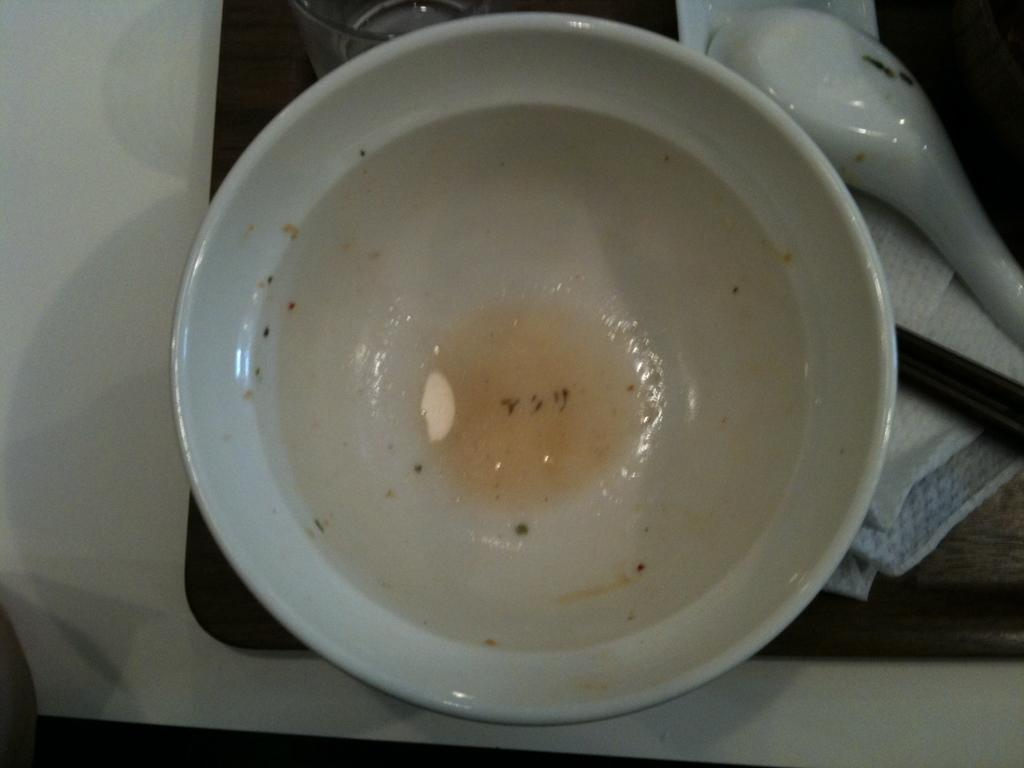What is located in the foreground area of the image? In the foreground area of the image, there is a bowl, a spoon, and a tissue. What might be used for eating the contents of the bowl? The spoon in the foreground area of the image can be used for eating the contents of the bowl. What item can be used for cleaning or drying in the image? The tissue in the foreground area of the image can be used for cleaning or drying. How are the items arranged in the image? The items are arranged on a tray in the image. How does the tissue cover the bowl in the image? The tissue does not cover the bowl in the image; it is a separate item on the tray. 